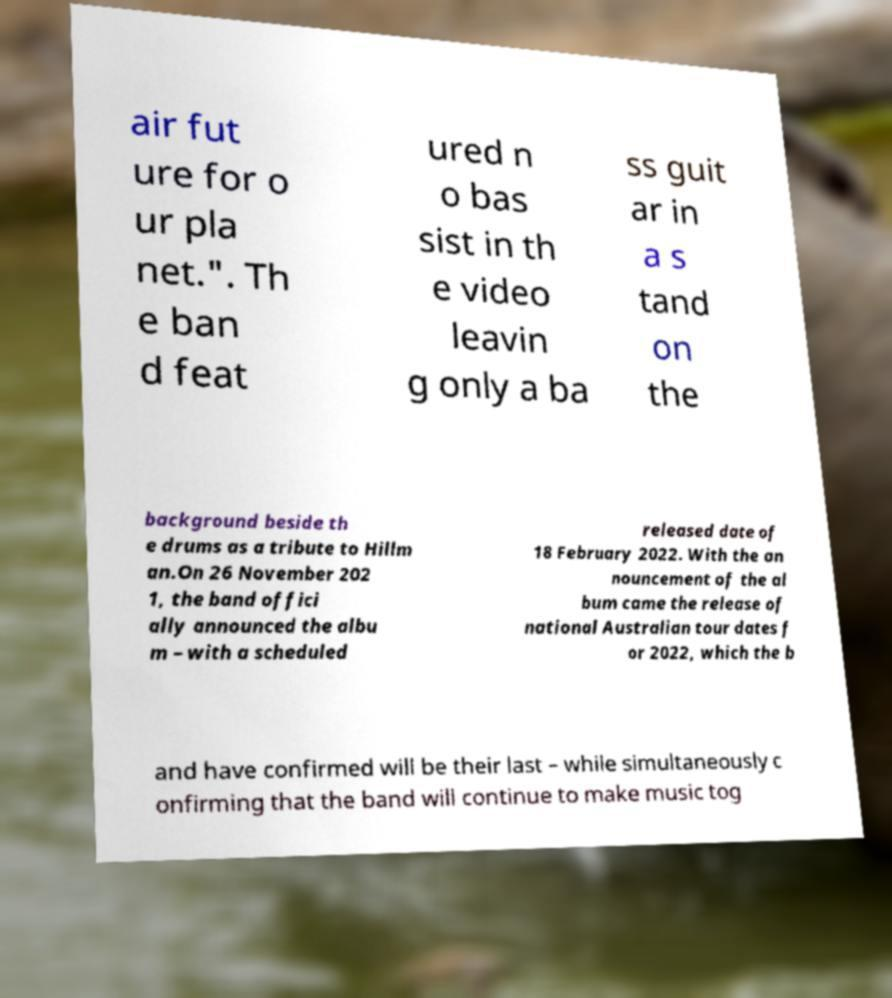I need the written content from this picture converted into text. Can you do that? air fut ure for o ur pla net.". Th e ban d feat ured n o bas sist in th e video leavin g only a ba ss guit ar in a s tand on the background beside th e drums as a tribute to Hillm an.On 26 November 202 1, the band offici ally announced the albu m – with a scheduled released date of 18 February 2022. With the an nouncement of the al bum came the release of national Australian tour dates f or 2022, which the b and have confirmed will be their last – while simultaneously c onfirming that the band will continue to make music tog 